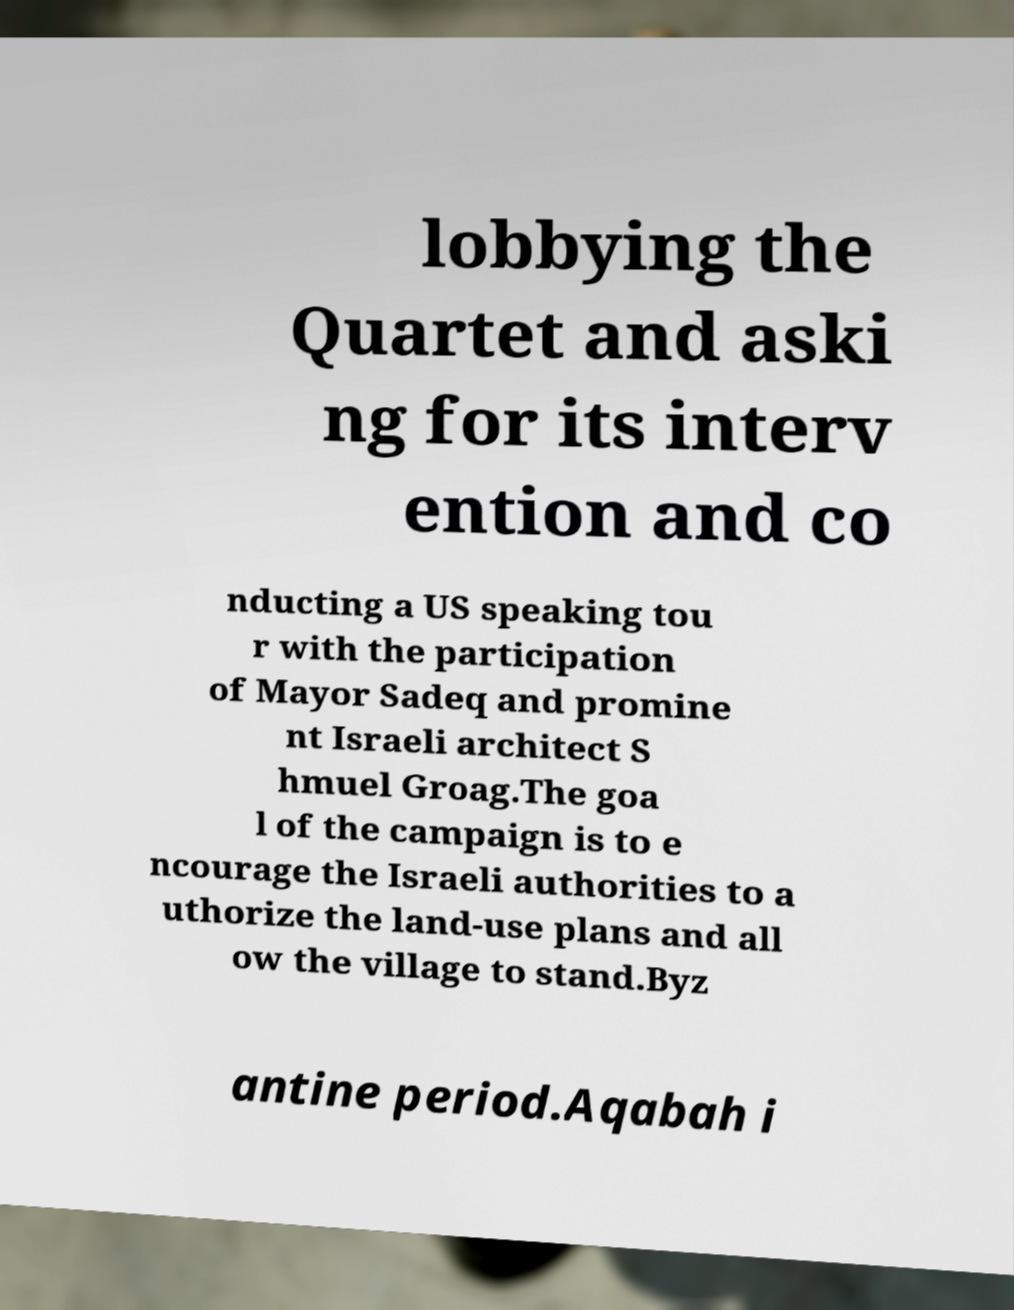What messages or text are displayed in this image? I need them in a readable, typed format. lobbying the Quartet and aski ng for its interv ention and co nducting a US speaking tou r with the participation of Mayor Sadeq and promine nt Israeli architect S hmuel Groag.The goa l of the campaign is to e ncourage the Israeli authorities to a uthorize the land-use plans and all ow the village to stand.Byz antine period.Aqabah i 